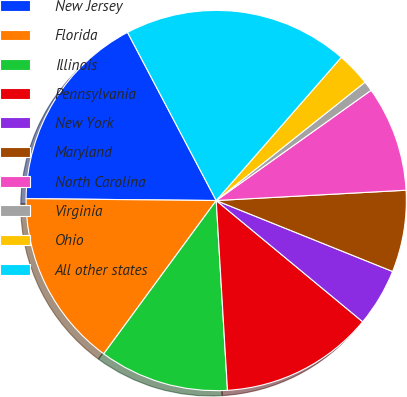<chart> <loc_0><loc_0><loc_500><loc_500><pie_chart><fcel>New Jersey<fcel>Florida<fcel>Illinois<fcel>Pennsylvania<fcel>New York<fcel>Maryland<fcel>North Carolina<fcel>Virginia<fcel>Ohio<fcel>All other states<nl><fcel>17.12%<fcel>15.08%<fcel>11.02%<fcel>13.05%<fcel>4.92%<fcel>6.95%<fcel>8.98%<fcel>0.85%<fcel>2.88%<fcel>19.15%<nl></chart> 